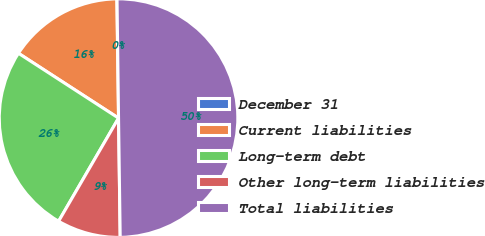<chart> <loc_0><loc_0><loc_500><loc_500><pie_chart><fcel>December 31<fcel>Current liabilities<fcel>Long-term debt<fcel>Other long-term liabilities<fcel>Total liabilities<nl><fcel>0.03%<fcel>15.62%<fcel>25.77%<fcel>8.6%<fcel>49.98%<nl></chart> 